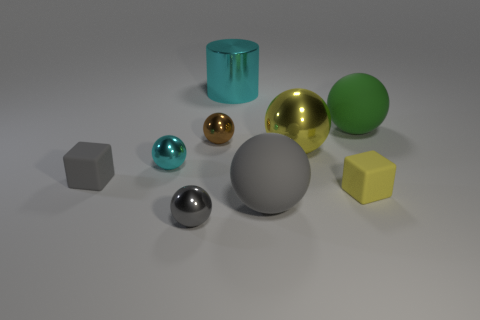There is a metal object that is both on the right side of the small brown object and in front of the green matte thing; what shape is it?
Ensure brevity in your answer.  Sphere. There is a thing that is both left of the large gray sphere and behind the brown ball; what color is it?
Make the answer very short. Cyan. Is the number of large green balls on the left side of the green matte thing greater than the number of yellow objects behind the tiny gray matte thing?
Keep it short and to the point. No. What is the color of the cylinder behind the tiny yellow matte block?
Give a very brief answer. Cyan. There is a cyan shiny object that is in front of the green rubber ball; does it have the same shape as the big yellow metallic object in front of the big cyan object?
Provide a short and direct response. Yes. Is there a gray sphere of the same size as the green rubber sphere?
Your answer should be compact. Yes. There is a yellow thing right of the yellow metallic object; what is it made of?
Offer a terse response. Rubber. Is the material of the big ball that is in front of the small cyan sphere the same as the green object?
Your answer should be compact. Yes. Is there a gray block?
Make the answer very short. Yes. What color is the other big ball that is made of the same material as the brown ball?
Keep it short and to the point. Yellow. 